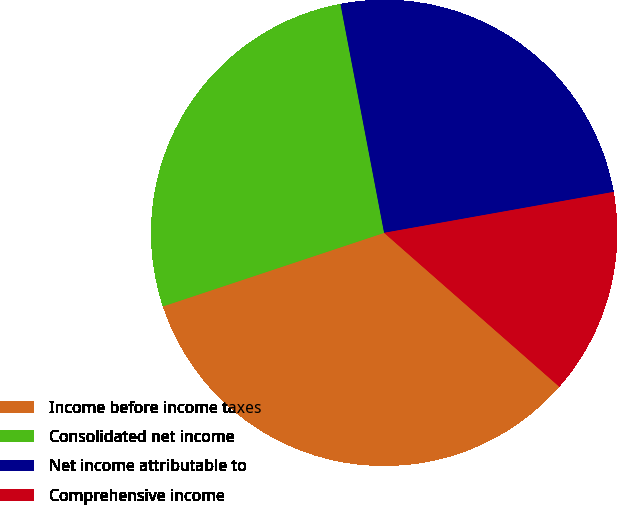Convert chart. <chart><loc_0><loc_0><loc_500><loc_500><pie_chart><fcel>Income before income taxes<fcel>Consolidated net income<fcel>Net income attributable to<fcel>Comprehensive income<nl><fcel>33.42%<fcel>27.11%<fcel>25.19%<fcel>14.28%<nl></chart> 